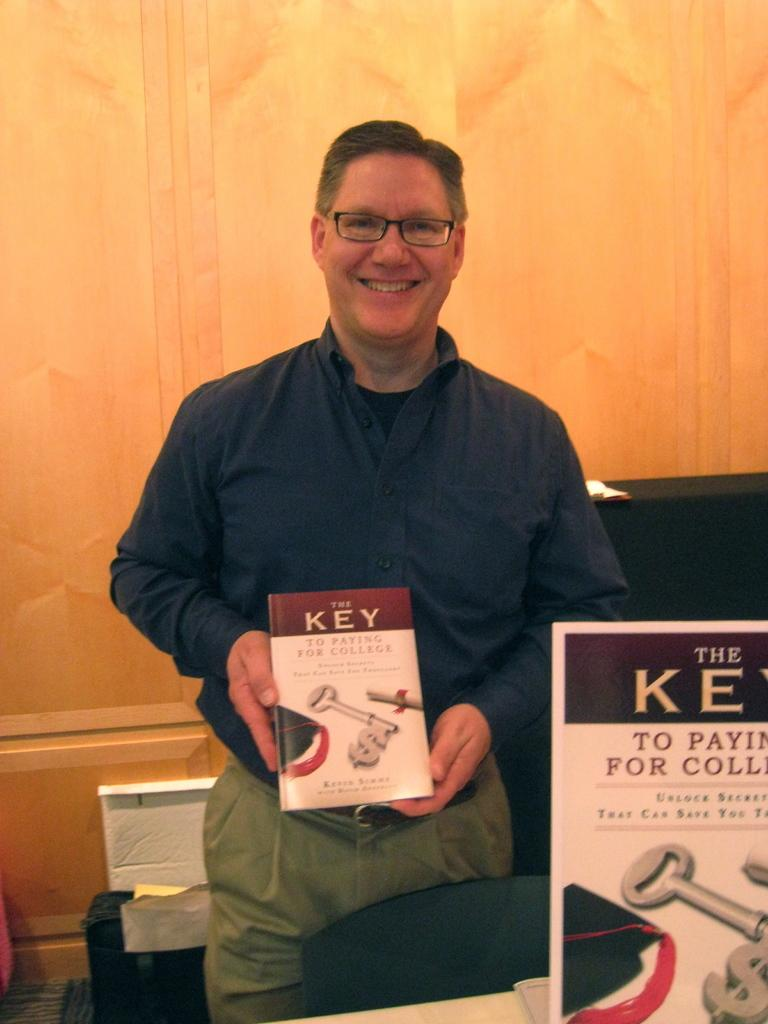<image>
Write a terse but informative summary of the picture. a man with a book that says key on it 